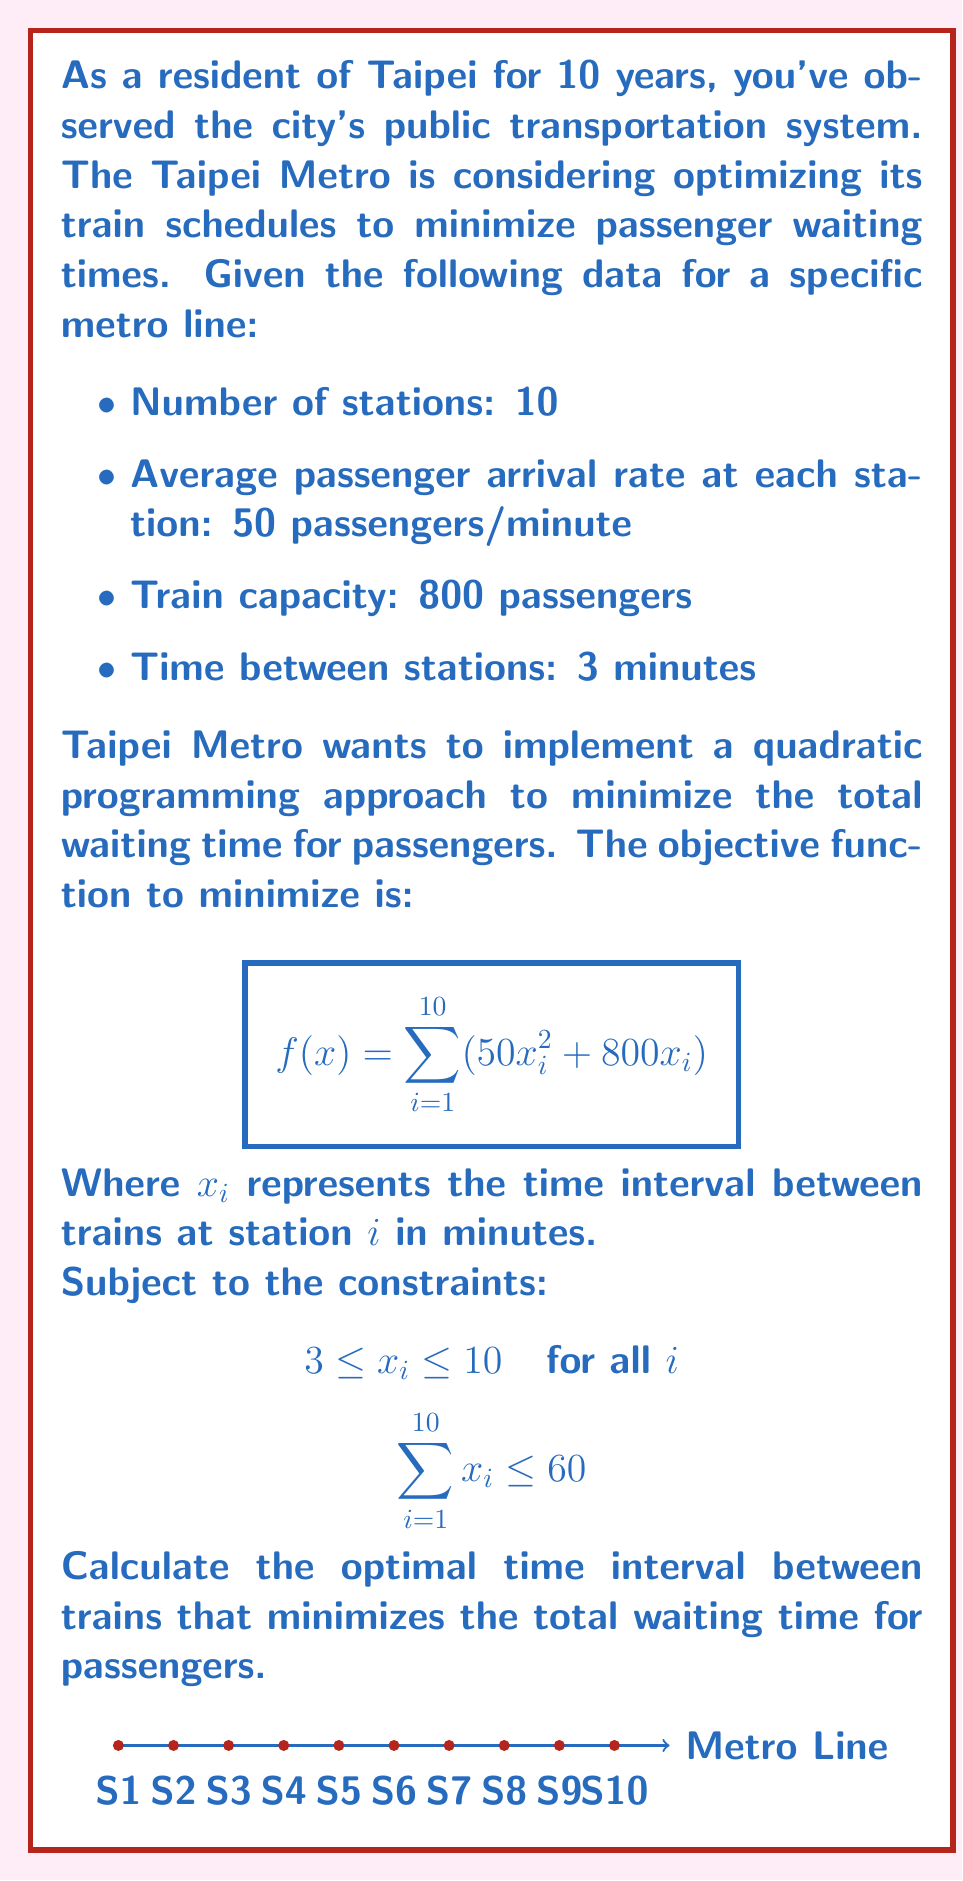Provide a solution to this math problem. To solve this optimization problem, we'll use the method of Lagrange multipliers for constrained optimization.

Step 1: Form the Lagrangian function
$$L(x_1, ..., x_{10}, \lambda, \mu_1, ..., \mu_{10}, \nu_1, ..., \nu_{10}) = \sum_{i=1}^{10} (50x_i^2 + 800x_i) + \lambda(\sum_{i=1}^{10} x_i - 60) + \sum_{i=1}^{10} \mu_i(3 - x_i) + \sum_{i=1}^{10} \nu_i(x_i - 10)$$

Step 2: Derive the KKT conditions
$$\frac{\partial L}{\partial x_i} = 100x_i + 800 + \lambda - \mu_i + \nu_i = 0 \quad \text{for } i = 1, ..., 10$$
$$\sum_{i=1}^{10} x_i \leq 60, \quad \lambda \geq 0, \quad \lambda(\sum_{i=1}^{10} x_i - 60) = 0$$
$$3 \leq x_i \leq 10, \quad \mu_i \geq 0, \quad \nu_i \geq 0, \quad \mu_i(3 - x_i) = 0, \quad \nu_i(x_i - 10) = 0 \quad \text{for } i = 1, ..., 10$$

Step 3: Solve the system of equations
Due to the symmetry of the problem, all $x_i$ will be equal. Let's call this common value $x$.

From the KKT conditions:
$$100x + 800 + \lambda - \mu + \nu = 0$$

Case 1: If $3 < x < 10$, then $\mu = \nu = 0$, and $\lambda > 0$ (active constraint)
$$100x + 800 + \lambda = 0$$
$$10x = 60 \quad \text{(from the active constraint)}$$
$$x = 6$$

Substituting back:
$$\lambda = -100(6) - 800 = -1400$$

This violates $\lambda \geq 0$, so this case is not valid.

Case 2: If $x = 3$, then $\mu > 0$, $\nu = 0$, and $\lambda = 0$ (inactive constraint)
$$100(3) + 800 - \mu = 0$$
$$\mu = 1100$$

This satisfies all conditions, so $x = 3$ is the optimal solution.

Step 4: Verify the solution
$$\sum_{i=1}^{10} x_i = 10(3) = 30 \leq 60$$

The solution satisfies all constraints and minimizes the objective function.
Answer: 3 minutes 